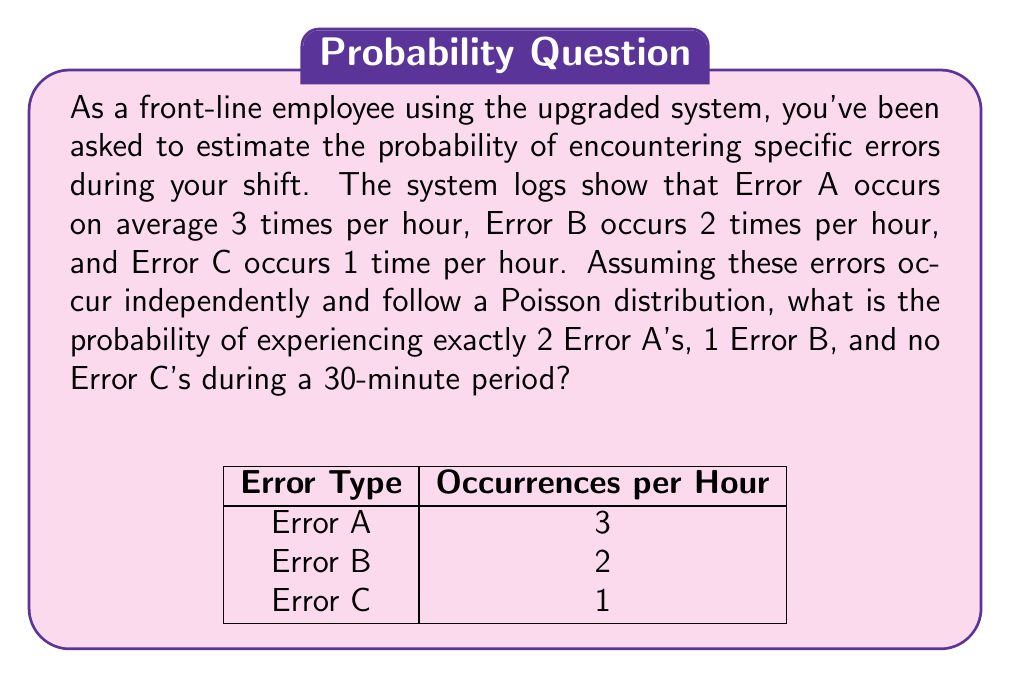Show me your answer to this math problem. Let's approach this step-by-step:

1) First, we need to adjust the average occurrences for a 30-minute period:
   Error A: $\lambda_A = 3 * 0.5 = 1.5$ per 30 minutes
   Error B: $\lambda_B = 2 * 0.5 = 1$ per 30 minutes
   Error C: $\lambda_C = 1 * 0.5 = 0.5$ per 30 minutes

2) The probability of each event occurring $k$ times in a Poisson distribution is given by:

   $$P(X = k) = \frac{e^{-\lambda}\lambda^k}{k!}$$

3) For Error A (exactly 2 occurrences):
   $$P(A = 2) = \frac{e^{-1.5}1.5^2}{2!} = \frac{e^{-1.5}2.25}{2}$$

4) For Error B (exactly 1 occurrence):
   $$P(B = 1) = \frac{e^{-1}1^1}{1!} = e^{-1}$$

5) For Error C (0 occurrences):
   $$P(C = 0) = \frac{e^{-0.5}0.5^0}{0!} = e^{-0.5}$$

6) Since these events are independent, we multiply their probabilities:

   $$P(\text{2A, 1B, 0C}) = P(A = 2) * P(B = 1) * P(C = 0)$$
   $$= \frac{e^{-1.5}2.25}{2} * e^{-1} * e^{-0.5}$$
   $$= \frac{2.25}{2} * e^{-3}$$
   $$= 1.125 * e^{-3}$$
   $$\approx 0.0566$$
Answer: $0.0566$ or $5.66\%$ 